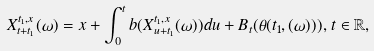<formula> <loc_0><loc_0><loc_500><loc_500>X _ { t + t _ { 1 } } ^ { t _ { 1 } , x } ( \omega ) = x + \int _ { 0 } ^ { t } b ( X _ { u + t _ { 1 } } ^ { t _ { 1 } , x } ( \omega ) ) d u + B _ { t } ( \theta ( t _ { 1 } , ( \omega ) ) ) , \, t \in \mathbb { R } ,</formula> 